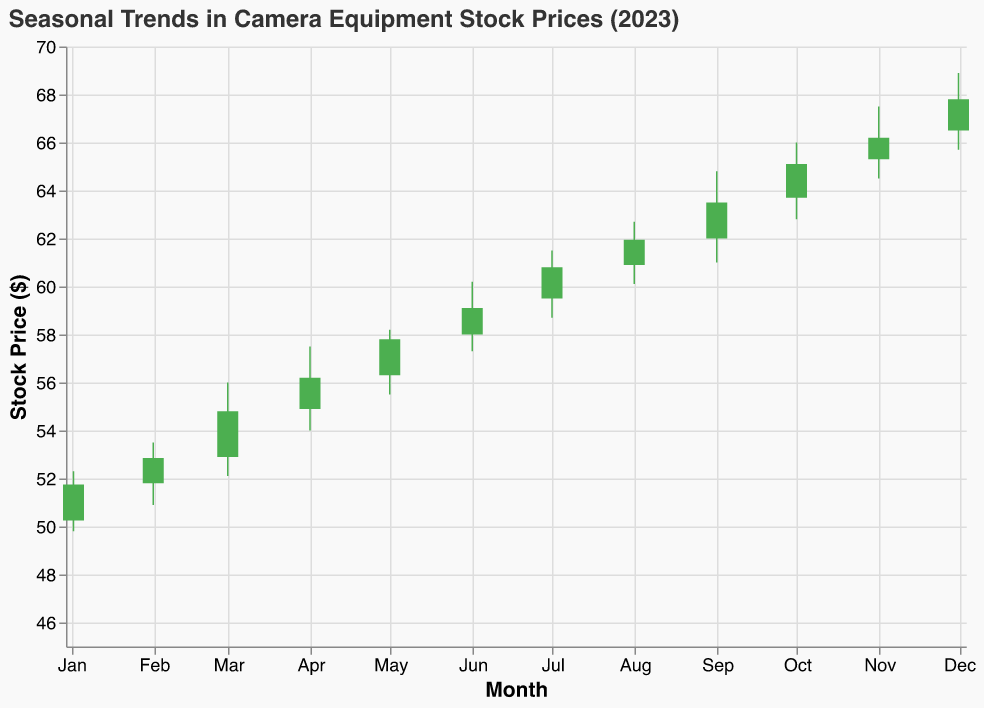What is the title of the plot? The title is displayed at the top of the plot in bold. It reads "Seasonal Trends in Camera Equipment Stock Prices (2023)".
Answer: Seasonal Trends in Camera Equipment Stock Prices (2023) What are the lowest and highest stock prices recorded in August? The chart for August shows a candlestick with the lowest point at $60.10 and the highest point at $62.70.
Answer: Low: $60.10, High: $62.70 Which month recorded the highest closing price? By looking at the top of the candlesticks where they end, December records the highest closing price of $67.80.
Answer: December How did the closing price in July compare to the opening price in July? The July data indicates the opening price at $59.50 and the closing price at $60.80. Comparing these, the closing price is higher than the opening price.
Answer: Higher What was the volume of stock traded in June and how does it compare to May? June had a trading volume of 52,000, while May had a trading volume of 50,000. The volume in June was 2,000 more than in May.
Answer: June had 2,000 more What month had the most significant difference between the high and low prices? Subtracting the low price from the high price for each month and comparing, September (64.80 - 61.00 = 3.80) shows the highest difference.
Answer: September How many months had an increase in the closing price compared to the opening price? By counting the green bars (closed higher than opened), January, February, March, April, May, June, July, August, September, October, and November all show this. December as well, totaling 12 months.
Answer: 12 months What was the average closing price for the year? Sum up all the closing prices and divide by the number of data points (months). The sum is 51.75 + 52.85 + 54.80 + 56.20 + 57.80 + 59.10 + 60.80 + 61.95 + 63.50 + 65.10 + 66.20 + 67.80 = 718.85. Average is 718.85/12 = 59.90
Answer: $59.90 